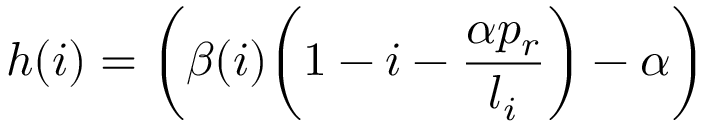<formula> <loc_0><loc_0><loc_500><loc_500>h ( i ) = \left ( \beta ( i ) \left ( 1 - i - \frac { \alpha p _ { r } } { l _ { i } } \right ) - \alpha \right )</formula> 